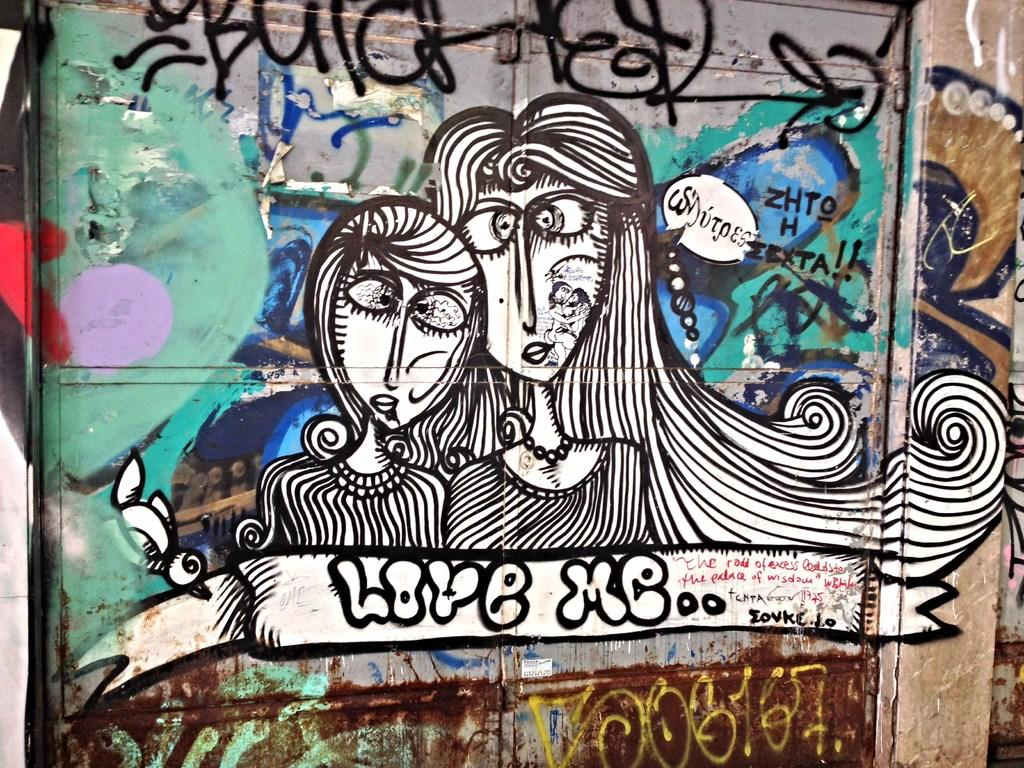What is depicted on the wall in the image? There is a graffiti painting on a wall in the image. Can you describe the graffiti painting? Unfortunately, the specific details of the graffiti painting cannot be determined from the provided facts. What is the primary purpose of the graffiti painting in the image? The purpose of the graffiti painting cannot be determined from the provided facts. What type of grip does the gun have in the image? There is no gun present in the image; it only features a graffiti painting on a wall. 